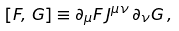Convert formula to latex. <formula><loc_0><loc_0><loc_500><loc_500>[ F , \, G ] \equiv \partial _ { \mu } F \, J ^ { \mu \nu } \, \partial _ { \nu } G \, ,</formula> 